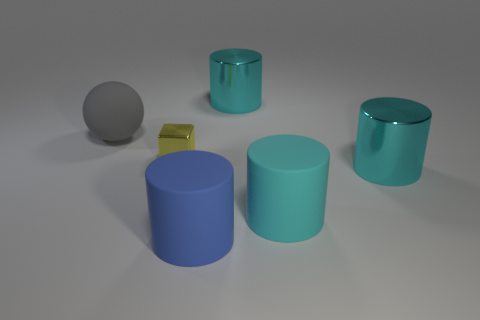Are there any reflective surfaces observed in the image? Yes, there are indeed reflective surfaces visible. The teal cylindrical containers have a glossy finish that reflects the environment, with muted reflections indicating a smooth but not perfectly mirror-like surface. 